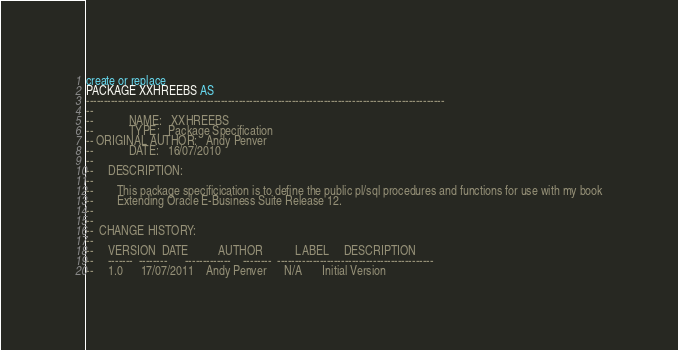<code> <loc_0><loc_0><loc_500><loc_500><_SQL_>create or replace
PACKAGE XXHREEBS AS
-----------------------------------------------------------------------------------------------------
--
--            NAME:   XXHREEBS
--            TYPE:   Package Specification
-- ORIGINAL AUTHOR:   Andy Penver
--            DATE:   16/07/2010
--
--     DESCRIPTION:
--
--        This package specificication is to define the public pl/sql procedures and functions for use with my book
--        Extending Oracle E-Business Suite Release 12.
--
--
--  CHANGE HISTORY:
--
--     VERSION  DATE          AUTHOR           LABEL     DESCRIPTION
--     -------  --------      -------------    --------  --------------------------------------------
--     1.0      17/07/2011    Andy Penver      N/A       Initial Version</code> 